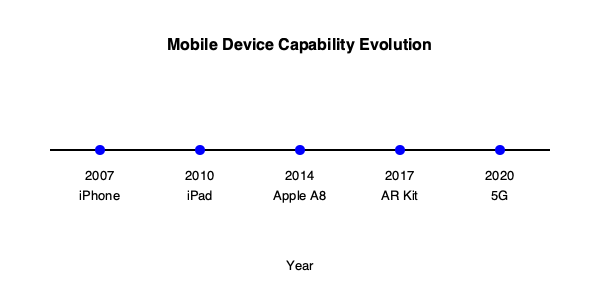Based on the timeline infographic, which technological advancement in mobile devices likely had the most significant impact on enabling complex 3D gaming experiences similar to those found in traditional arcade games? To answer this question, we need to analyze each milestone in the timeline and its potential impact on mobile gaming:

1. 2007 - iPhone: This marked the beginning of modern smartphones, but early models had limited processing power for complex games.

2. 2010 - iPad: Introduced larger screens, improving the gaming experience, but still lacked power for advanced 3D graphics.

3. 2014 - Apple A8: This represents a significant leap in mobile processor technology. The A8 chip dramatically increased computational and graphics processing power, enabling more complex 3D games.

4. 2017 - AR Kit: While important for augmented reality, it's not directly related to replicating traditional arcade-style gaming.

5. 2020 - 5G: Improves online gaming capabilities but doesn't directly affect the device's ability to run complex 3D games.

The Apple A8 chip in 2014 stands out as the most impactful for enabling complex 3D gaming experiences. It provided the necessary processing power and graphics capabilities to run games that could rival the visual complexity of traditional arcade games. This advancement allowed mobile devices to handle the demanding requirements of 3D rendering, physics simulations, and complex game logic, which are essential for recreating arcade-like experiences on mobile platforms.
Answer: Apple A8 chip (2014) 